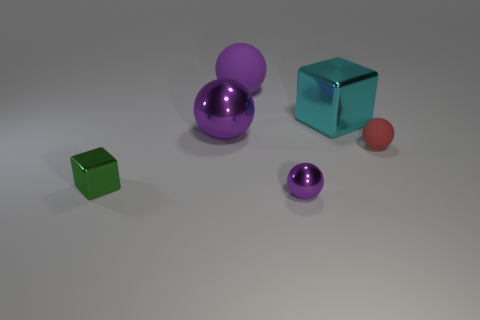Subtract all big rubber balls. How many balls are left? 3 Add 2 cyan metallic things. How many objects exist? 8 Subtract 1 cubes. How many cubes are left? 1 Add 5 big purple rubber balls. How many big purple rubber balls are left? 6 Add 2 small gray shiny things. How many small gray shiny things exist? 2 Subtract all red spheres. How many spheres are left? 3 Subtract 0 yellow blocks. How many objects are left? 6 Subtract all cubes. How many objects are left? 4 Subtract all cyan cubes. Subtract all yellow spheres. How many cubes are left? 1 Subtract all cyan balls. How many brown cubes are left? 0 